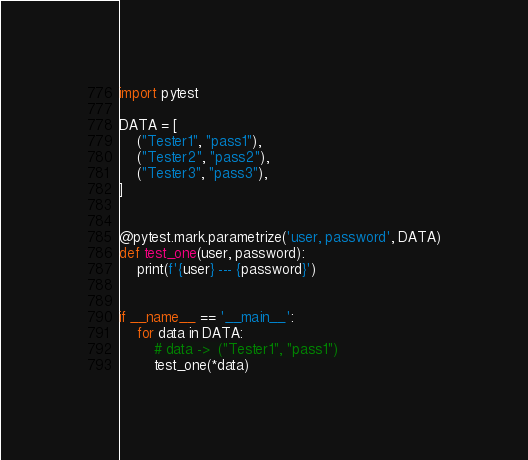<code> <loc_0><loc_0><loc_500><loc_500><_Python_>import pytest

DATA = [
    ("Tester1", "pass1"),
    ("Tester2", "pass2"),
    ("Tester3", "pass3"),
]


@pytest.mark.parametrize('user, password', DATA)
def test_one(user, password):
    print(f'{user} --- {password}')


if __name__ == '__main__':
    for data in DATA:
        # data ->  ("Tester1", "pass1")
        test_one(*data)
</code> 